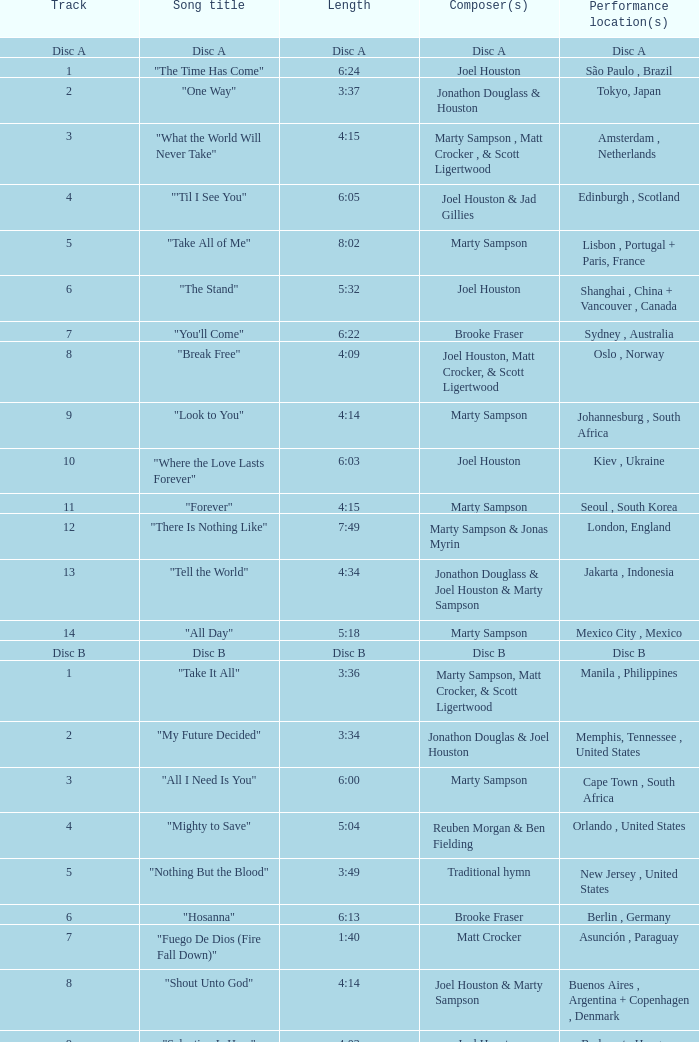Who is the composer of the song with a length of 6:24? Joel Houston. 